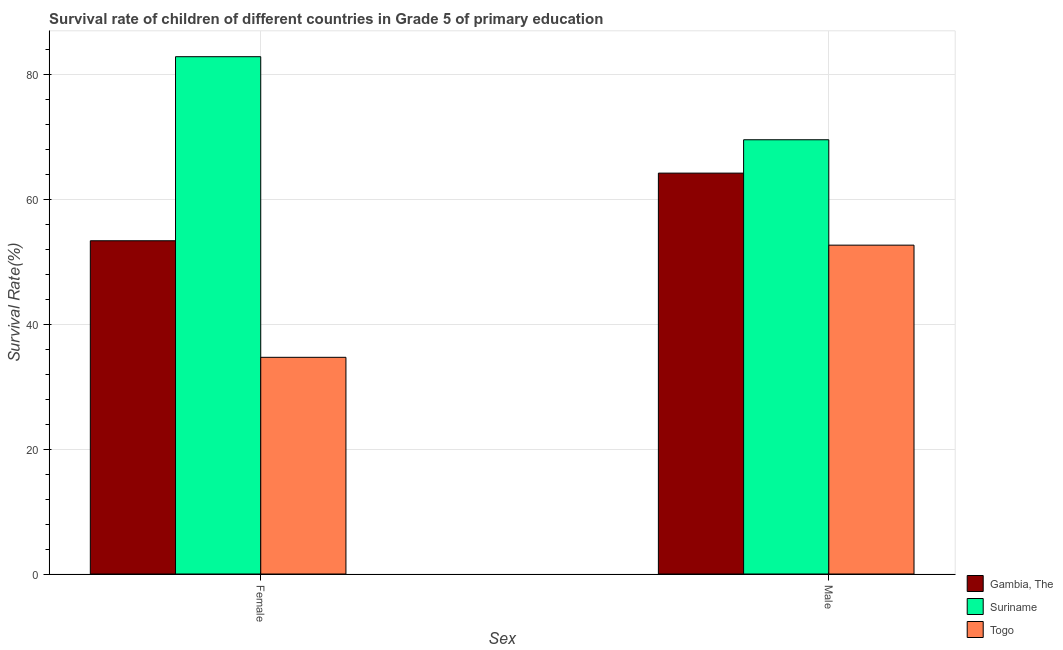How many different coloured bars are there?
Ensure brevity in your answer.  3. How many groups of bars are there?
Offer a terse response. 2. Are the number of bars on each tick of the X-axis equal?
Your answer should be very brief. Yes. What is the label of the 2nd group of bars from the left?
Offer a very short reply. Male. What is the survival rate of female students in primary education in Togo?
Your answer should be very brief. 34.7. Across all countries, what is the maximum survival rate of male students in primary education?
Give a very brief answer. 69.55. Across all countries, what is the minimum survival rate of female students in primary education?
Make the answer very short. 34.7. In which country was the survival rate of female students in primary education maximum?
Provide a short and direct response. Suriname. In which country was the survival rate of male students in primary education minimum?
Offer a terse response. Togo. What is the total survival rate of female students in primary education in the graph?
Offer a very short reply. 170.93. What is the difference between the survival rate of female students in primary education in Gambia, The and that in Suriname?
Provide a succinct answer. -29.48. What is the difference between the survival rate of male students in primary education in Togo and the survival rate of female students in primary education in Suriname?
Give a very brief answer. -30.18. What is the average survival rate of female students in primary education per country?
Ensure brevity in your answer.  56.98. What is the difference between the survival rate of male students in primary education and survival rate of female students in primary education in Gambia, The?
Ensure brevity in your answer.  10.83. What is the ratio of the survival rate of female students in primary education in Togo to that in Gambia, The?
Your answer should be compact. 0.65. Is the survival rate of female students in primary education in Suriname less than that in Gambia, The?
Ensure brevity in your answer.  No. What does the 3rd bar from the left in Female represents?
Give a very brief answer. Togo. What does the 3rd bar from the right in Male represents?
Offer a terse response. Gambia, The. How many bars are there?
Your response must be concise. 6. Are all the bars in the graph horizontal?
Your response must be concise. No. How many countries are there in the graph?
Your response must be concise. 3. Does the graph contain any zero values?
Your answer should be compact. No. Does the graph contain grids?
Offer a very short reply. Yes. Where does the legend appear in the graph?
Your answer should be compact. Bottom right. How many legend labels are there?
Provide a short and direct response. 3. How are the legend labels stacked?
Your answer should be compact. Vertical. What is the title of the graph?
Provide a succinct answer. Survival rate of children of different countries in Grade 5 of primary education. What is the label or title of the X-axis?
Offer a very short reply. Sex. What is the label or title of the Y-axis?
Offer a very short reply. Survival Rate(%). What is the Survival Rate(%) in Gambia, The in Female?
Keep it short and to the point. 53.37. What is the Survival Rate(%) of Suriname in Female?
Provide a short and direct response. 82.85. What is the Survival Rate(%) of Togo in Female?
Offer a very short reply. 34.7. What is the Survival Rate(%) in Gambia, The in Male?
Your answer should be very brief. 64.21. What is the Survival Rate(%) of Suriname in Male?
Keep it short and to the point. 69.55. What is the Survival Rate(%) of Togo in Male?
Provide a succinct answer. 52.67. Across all Sex, what is the maximum Survival Rate(%) of Gambia, The?
Provide a short and direct response. 64.21. Across all Sex, what is the maximum Survival Rate(%) of Suriname?
Provide a succinct answer. 82.85. Across all Sex, what is the maximum Survival Rate(%) of Togo?
Your answer should be very brief. 52.67. Across all Sex, what is the minimum Survival Rate(%) of Gambia, The?
Make the answer very short. 53.37. Across all Sex, what is the minimum Survival Rate(%) of Suriname?
Your answer should be compact. 69.55. Across all Sex, what is the minimum Survival Rate(%) in Togo?
Ensure brevity in your answer.  34.7. What is the total Survival Rate(%) in Gambia, The in the graph?
Keep it short and to the point. 117.58. What is the total Survival Rate(%) in Suriname in the graph?
Offer a very short reply. 152.4. What is the total Survival Rate(%) in Togo in the graph?
Provide a short and direct response. 87.37. What is the difference between the Survival Rate(%) in Gambia, The in Female and that in Male?
Provide a succinct answer. -10.83. What is the difference between the Survival Rate(%) of Suriname in Female and that in Male?
Provide a succinct answer. 13.3. What is the difference between the Survival Rate(%) of Togo in Female and that in Male?
Offer a terse response. -17.97. What is the difference between the Survival Rate(%) of Gambia, The in Female and the Survival Rate(%) of Suriname in Male?
Your answer should be compact. -16.18. What is the difference between the Survival Rate(%) in Gambia, The in Female and the Survival Rate(%) in Togo in Male?
Your answer should be compact. 0.7. What is the difference between the Survival Rate(%) of Suriname in Female and the Survival Rate(%) of Togo in Male?
Provide a short and direct response. 30.18. What is the average Survival Rate(%) in Gambia, The per Sex?
Make the answer very short. 58.79. What is the average Survival Rate(%) of Suriname per Sex?
Offer a terse response. 76.2. What is the average Survival Rate(%) of Togo per Sex?
Your answer should be very brief. 43.69. What is the difference between the Survival Rate(%) of Gambia, The and Survival Rate(%) of Suriname in Female?
Your response must be concise. -29.48. What is the difference between the Survival Rate(%) in Gambia, The and Survival Rate(%) in Togo in Female?
Your response must be concise. 18.67. What is the difference between the Survival Rate(%) of Suriname and Survival Rate(%) of Togo in Female?
Your answer should be compact. 48.15. What is the difference between the Survival Rate(%) of Gambia, The and Survival Rate(%) of Suriname in Male?
Keep it short and to the point. -5.34. What is the difference between the Survival Rate(%) of Gambia, The and Survival Rate(%) of Togo in Male?
Make the answer very short. 11.54. What is the difference between the Survival Rate(%) in Suriname and Survival Rate(%) in Togo in Male?
Give a very brief answer. 16.88. What is the ratio of the Survival Rate(%) of Gambia, The in Female to that in Male?
Your response must be concise. 0.83. What is the ratio of the Survival Rate(%) in Suriname in Female to that in Male?
Your answer should be very brief. 1.19. What is the ratio of the Survival Rate(%) in Togo in Female to that in Male?
Your response must be concise. 0.66. What is the difference between the highest and the second highest Survival Rate(%) of Gambia, The?
Keep it short and to the point. 10.83. What is the difference between the highest and the second highest Survival Rate(%) of Suriname?
Give a very brief answer. 13.3. What is the difference between the highest and the second highest Survival Rate(%) in Togo?
Keep it short and to the point. 17.97. What is the difference between the highest and the lowest Survival Rate(%) of Gambia, The?
Provide a succinct answer. 10.83. What is the difference between the highest and the lowest Survival Rate(%) of Suriname?
Provide a succinct answer. 13.3. What is the difference between the highest and the lowest Survival Rate(%) of Togo?
Your response must be concise. 17.97. 